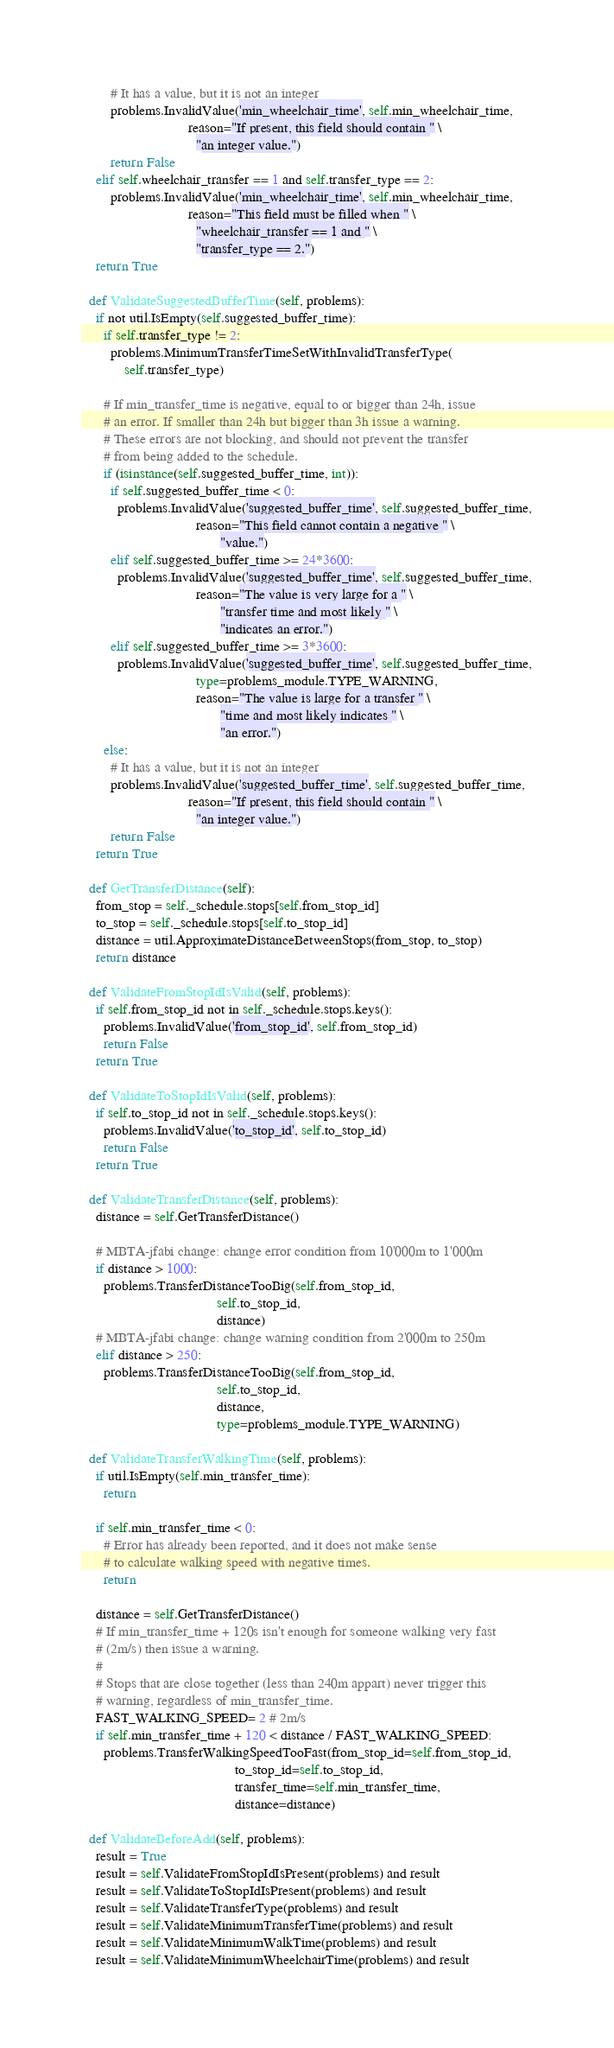<code> <loc_0><loc_0><loc_500><loc_500><_Python_>        # It has a value, but it is not an integer
        problems.InvalidValue('min_wheelchair_time', self.min_wheelchair_time,
                              reason="If present, this field should contain " \
                                "an integer value.")
        return False
    elif self.wheelchair_transfer == 1 and self.transfer_type == 2:
    	problems.InvalidValue('min_wheelchair_time', self.min_wheelchair_time,
                              reason="This field must be filled when " \
                                "wheelchair_transfer == 1 and " \
                                "transfer_type == 2.")
    return True

  def ValidateSuggestedBufferTime(self, problems):
    if not util.IsEmpty(self.suggested_buffer_time):
      if self.transfer_type != 2:
        problems.MinimumTransferTimeSetWithInvalidTransferType(
            self.transfer_type)

      # If min_transfer_time is negative, equal to or bigger than 24h, issue
      # an error. If smaller than 24h but bigger than 3h issue a warning.
      # These errors are not blocking, and should not prevent the transfer
      # from being added to the schedule.
      if (isinstance(self.suggested_buffer_time, int)):
        if self.suggested_buffer_time < 0:
          problems.InvalidValue('suggested_buffer_time', self.suggested_buffer_time,
                                reason="This field cannot contain a negative " \
                                       "value.")
        elif self.suggested_buffer_time >= 24*3600:
          problems.InvalidValue('suggested_buffer_time', self.suggested_buffer_time,
                                reason="The value is very large for a " \
                                       "transfer time and most likely " \
                                       "indicates an error.")
        elif self.suggested_buffer_time >= 3*3600:
          problems.InvalidValue('suggested_buffer_time', self.suggested_buffer_time,
                                type=problems_module.TYPE_WARNING,
                                reason="The value is large for a transfer " \
                                       "time and most likely indicates " \
                                       "an error.")
      else:
        # It has a value, but it is not an integer
        problems.InvalidValue('suggested_buffer_time', self.suggested_buffer_time,
                              reason="If present, this field should contain " \
                                "an integer value.")
        return False
    return True

  def GetTransferDistance(self):
    from_stop = self._schedule.stops[self.from_stop_id]
    to_stop = self._schedule.stops[self.to_stop_id]
    distance = util.ApproximateDistanceBetweenStops(from_stop, to_stop)
    return distance

  def ValidateFromStopIdIsValid(self, problems):
    if self.from_stop_id not in self._schedule.stops.keys():
      problems.InvalidValue('from_stop_id', self.from_stop_id)
      return False
    return True

  def ValidateToStopIdIsValid(self, problems):
    if self.to_stop_id not in self._schedule.stops.keys():
      problems.InvalidValue('to_stop_id', self.to_stop_id)
      return False
    return True

  def ValidateTransferDistance(self, problems):
    distance = self.GetTransferDistance()

    # MBTA-jfabi change: change error condition from 10'000m to 1'000m
    if distance > 1000:
      problems.TransferDistanceTooBig(self.from_stop_id,
                                      self.to_stop_id,
                                      distance)
    # MBTA-jfabi change: change warning condition from 2'000m to 250m
    elif distance > 250:
      problems.TransferDistanceTooBig(self.from_stop_id,
                                      self.to_stop_id,
                                      distance,
                                      type=problems_module.TYPE_WARNING)

  def ValidateTransferWalkingTime(self, problems):
    if util.IsEmpty(self.min_transfer_time):
      return

    if self.min_transfer_time < 0:
      # Error has already been reported, and it does not make sense
      # to calculate walking speed with negative times.
      return

    distance = self.GetTransferDistance()
    # If min_transfer_time + 120s isn't enough for someone walking very fast
    # (2m/s) then issue a warning.
    #
    # Stops that are close together (less than 240m appart) never trigger this
    # warning, regardless of min_transfer_time.
    FAST_WALKING_SPEED= 2 # 2m/s
    if self.min_transfer_time + 120 < distance / FAST_WALKING_SPEED:
      problems.TransferWalkingSpeedTooFast(from_stop_id=self.from_stop_id,
                                           to_stop_id=self.to_stop_id,
                                           transfer_time=self.min_transfer_time,
                                           distance=distance)

  def ValidateBeforeAdd(self, problems):
    result = True
    result = self.ValidateFromStopIdIsPresent(problems) and result
    result = self.ValidateToStopIdIsPresent(problems) and result
    result = self.ValidateTransferType(problems) and result
    result = self.ValidateMinimumTransferTime(problems) and result
    result = self.ValidateMinimumWalkTime(problems) and result
    result = self.ValidateMinimumWheelchairTime(problems) and result</code> 